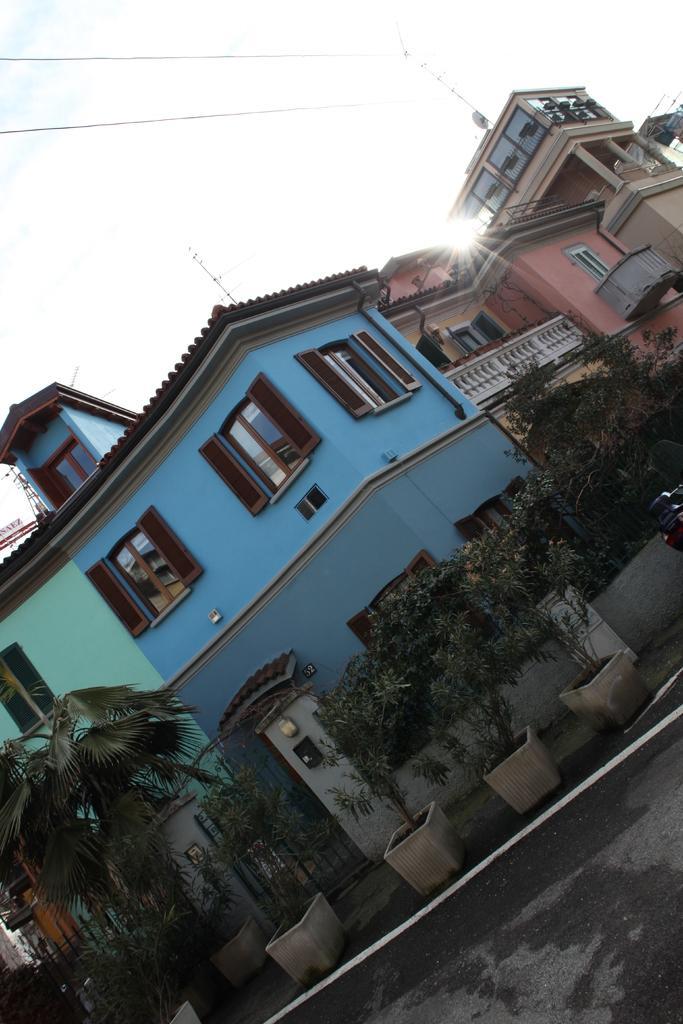In one or two sentences, can you explain what this image depicts? In this image we can see the road, flower pots, gate, fence, a vehicle here, buildings, some wires and the sky in the background. 